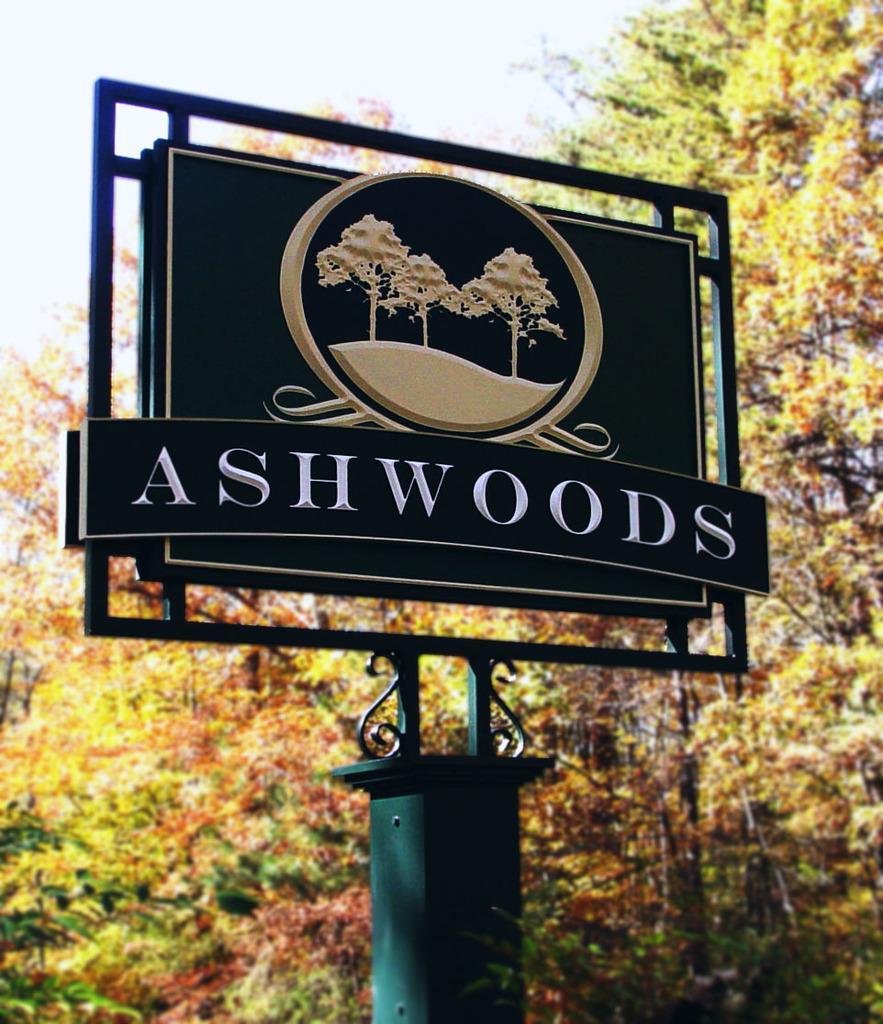Can you describe this image briefly? In this picture we can see board to the pillar, behind we can see some trees. 